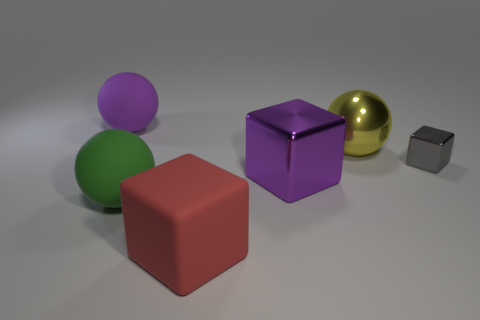Subtract all blue blocks. Subtract all green balls. How many blocks are left? 3 Add 3 tiny yellow rubber cylinders. How many objects exist? 9 Subtract 0 cyan balls. How many objects are left? 6 Subtract all tiny gray matte cubes. Subtract all red objects. How many objects are left? 5 Add 1 tiny gray objects. How many tiny gray objects are left? 2 Add 6 small blocks. How many small blocks exist? 7 